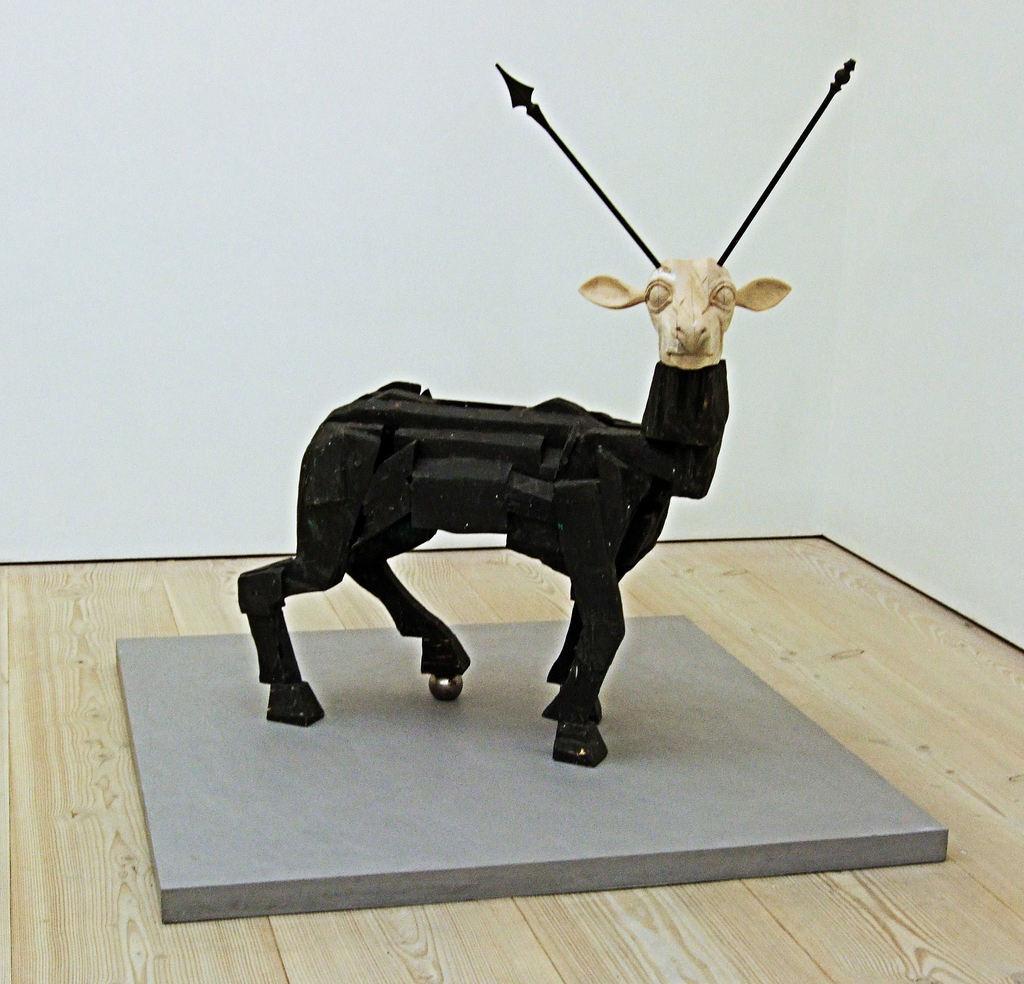How would you summarize this image in a sentence or two? In the foreground of this picture, there is a animal sculpture and it looks like deer. In the background, there is a white wall. 